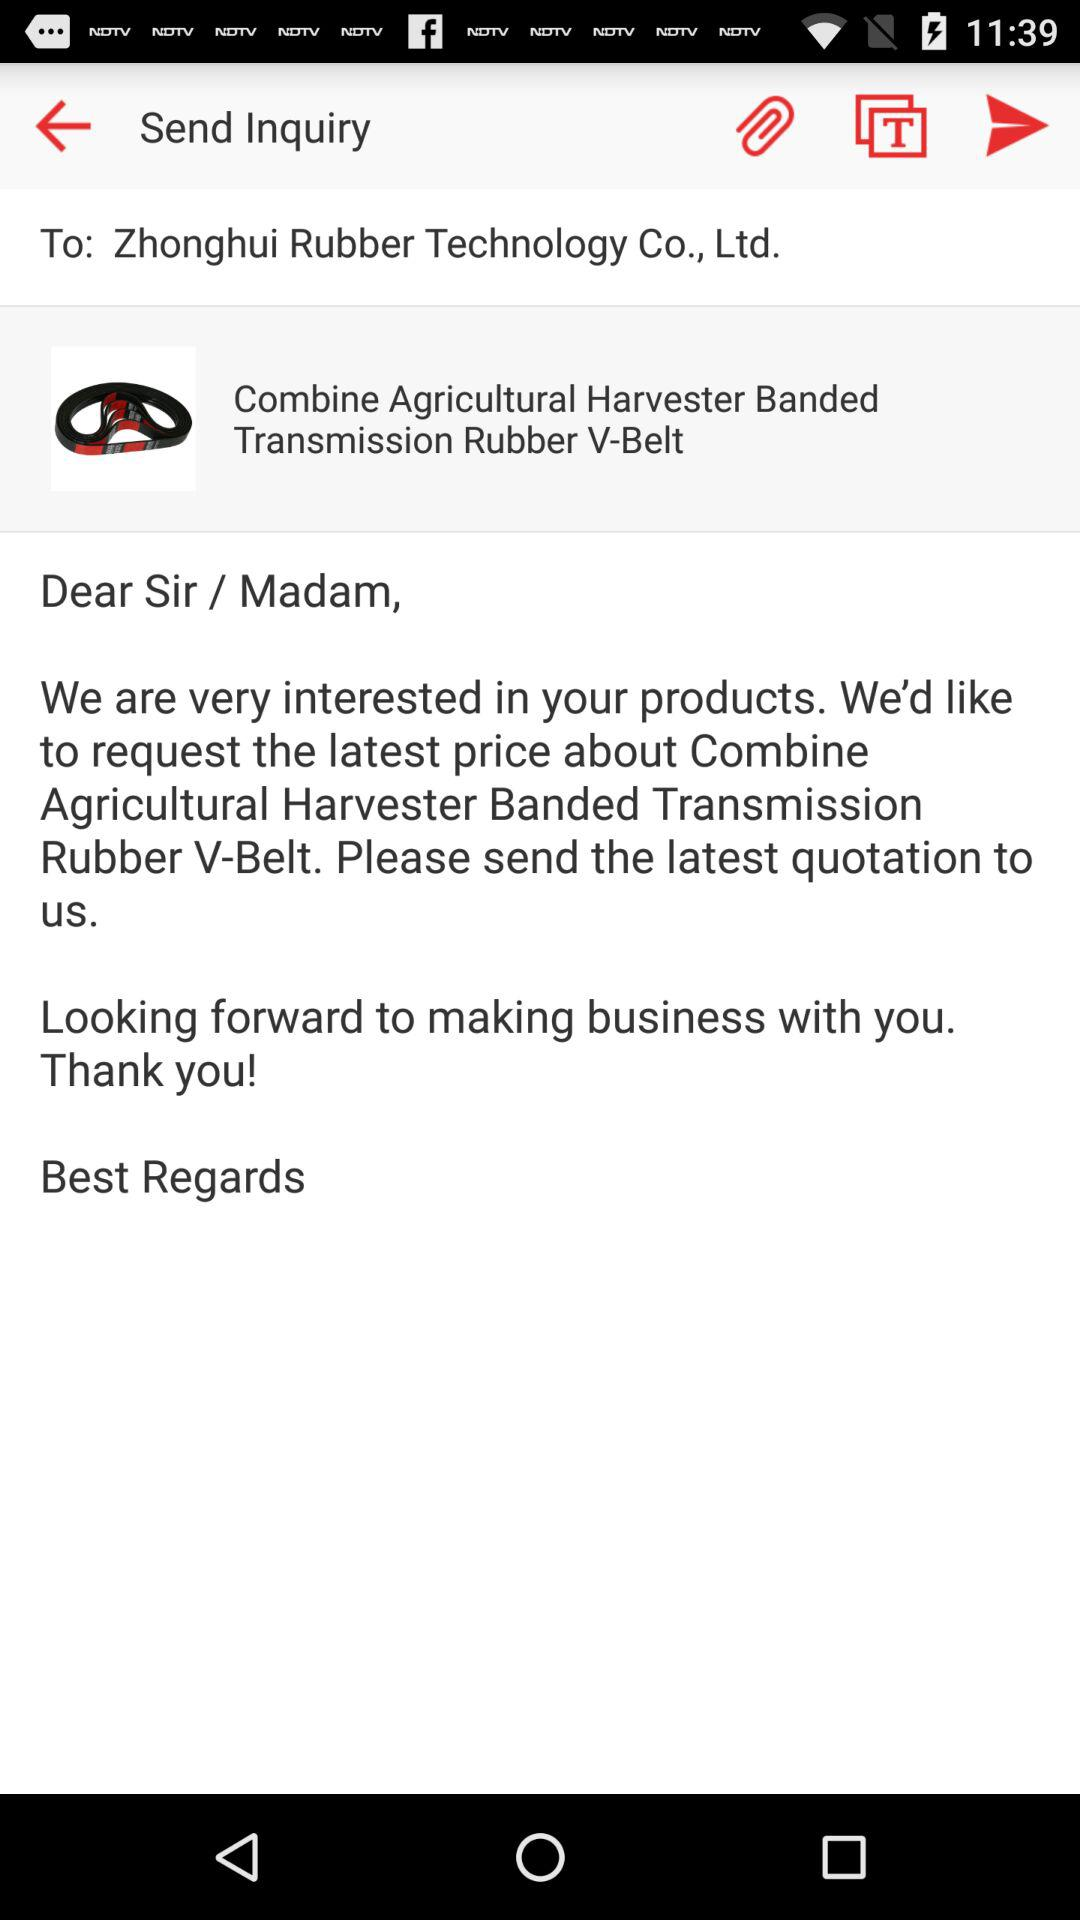What is the product name? The product name is Combine Agricultural Harvester Banded Transmission Rubber V-Belt. 